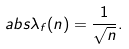<formula> <loc_0><loc_0><loc_500><loc_500>\ a b s { \lambda _ { f } ( n ) } = \frac { 1 } { \sqrt { n } } .</formula> 